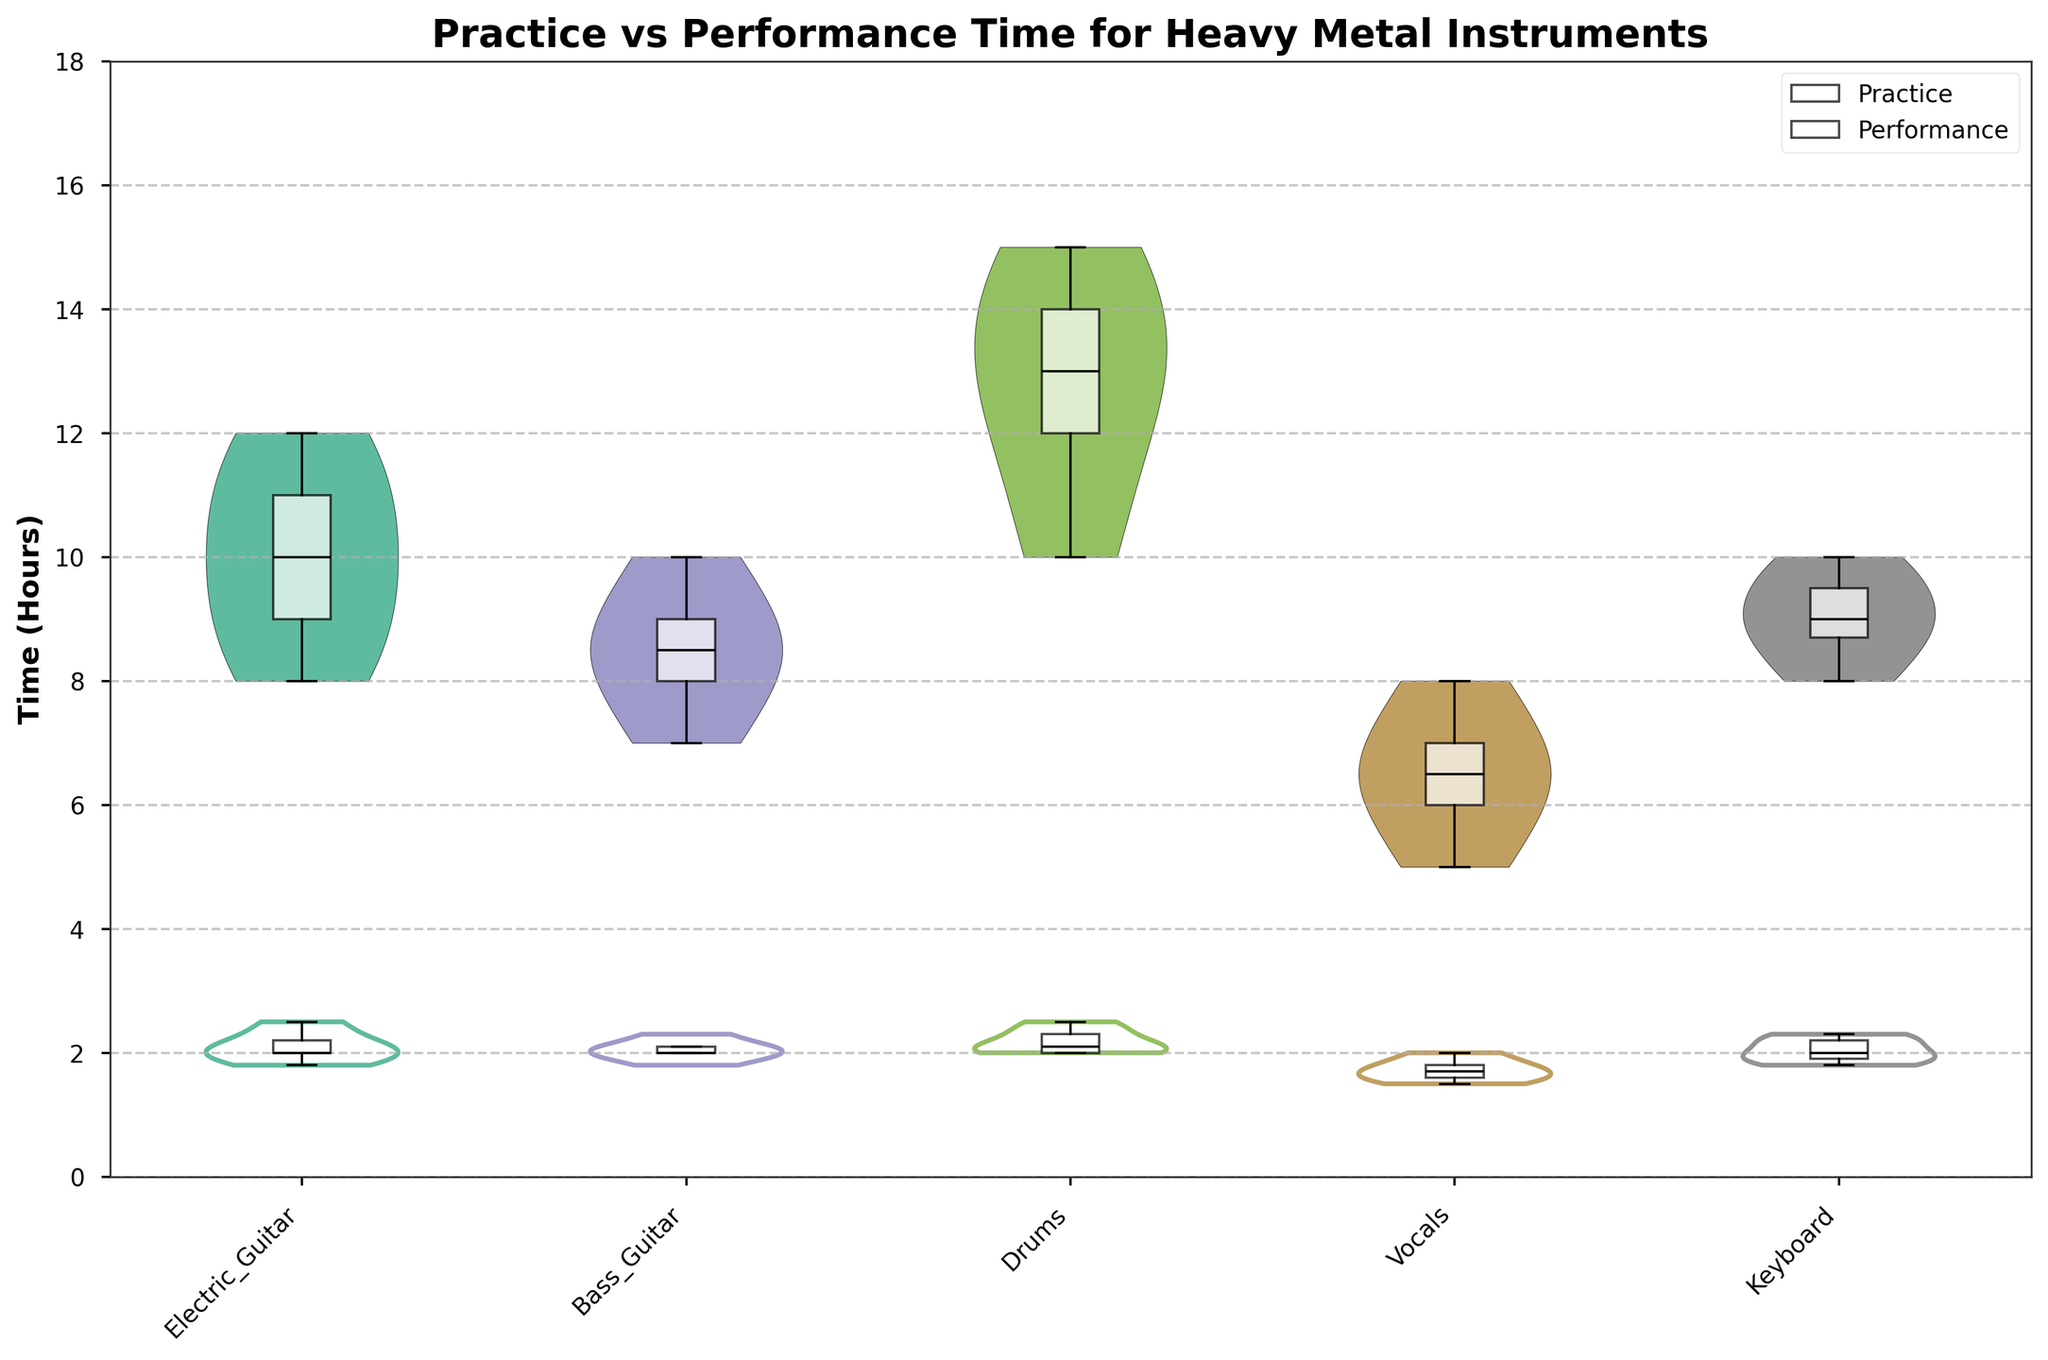How many instruments are shown in the chart? By counting the unique instruments on the x-axis, we see "Electric Guitar", "Bass Guitar", "Drums", "Vocals", and "Keyboard", which sums up to five instruments.
Answer: Five What is the range of practice times for Drums? The range for practice times can be determined by looking at the spread of the violin plot for Drums. It appears to span from 10 to 15 hours.
Answer: 10 to 15 hours Which instrument has the highest median practice time? By observing the box plots overlaying the violin plots, the instrument with the highest median practice time shows the median line closest to the top. Drums appear to have the highest median value.
Answer: Drums Is the median performance time higher for Bass Guitar or Keyboard? Comparing the positions of the median lines for performance times in the box plots for Bass Guitar and Keyboard, it is seen that Keyboard has a slightly higher median performance time.
Answer: Keyboard Do musicians typically spend more time practicing or performing? Overall violin plot widths and box plot positions show that practice times are higher across all instruments compared to performance times.
Answer: Practicing What is the median performance time for Vocals? By looking at the box plot for performance times in the Vocals category, the median line indicates a value of around 1.7 hours.
Answer: 1.7 hours Which instrument shows the greatest variability in practice times? The widest spread in the violin plot for practice times indicates the greatest variability, which appears to be Drums.
Answer: Drums Is there any instrument where the performance time appears to have an outlier? By looking for circles outside the box plot, which represent outliers, none appears to show noticeable outliers in performance times.
Answer: No How does the average practice time for Electric Guitar compare to Bass Guitar? By estimating the heights and spreads of the violin plots, Electric Guitar appears to have slightly higher average practice times than Bass Guitar.
Answer: Electric Guitar higher What's the typical performance time for the majority of instruments? The majority of performance times, shown by the bulk of the widths of the violin plots, hover around 2 hours for most instruments.
Answer: Around 2 hours 